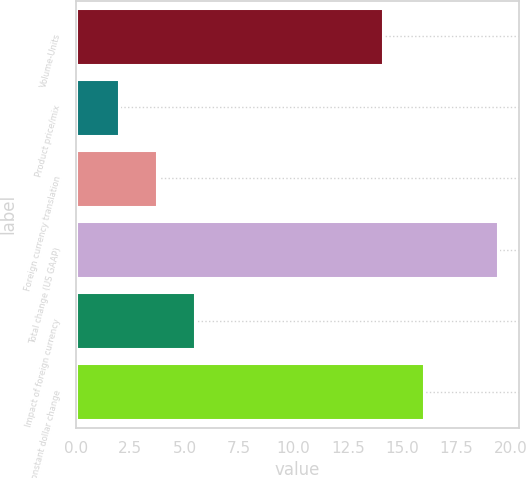Convert chart to OTSL. <chart><loc_0><loc_0><loc_500><loc_500><bar_chart><fcel>Volume-Units<fcel>Product price/mix<fcel>Foreign currency translation<fcel>Total change (US GAAP)<fcel>Impact of foreign currency<fcel>Total constant dollar change<nl><fcel>14.1<fcel>2<fcel>3.74<fcel>19.4<fcel>5.48<fcel>16<nl></chart> 